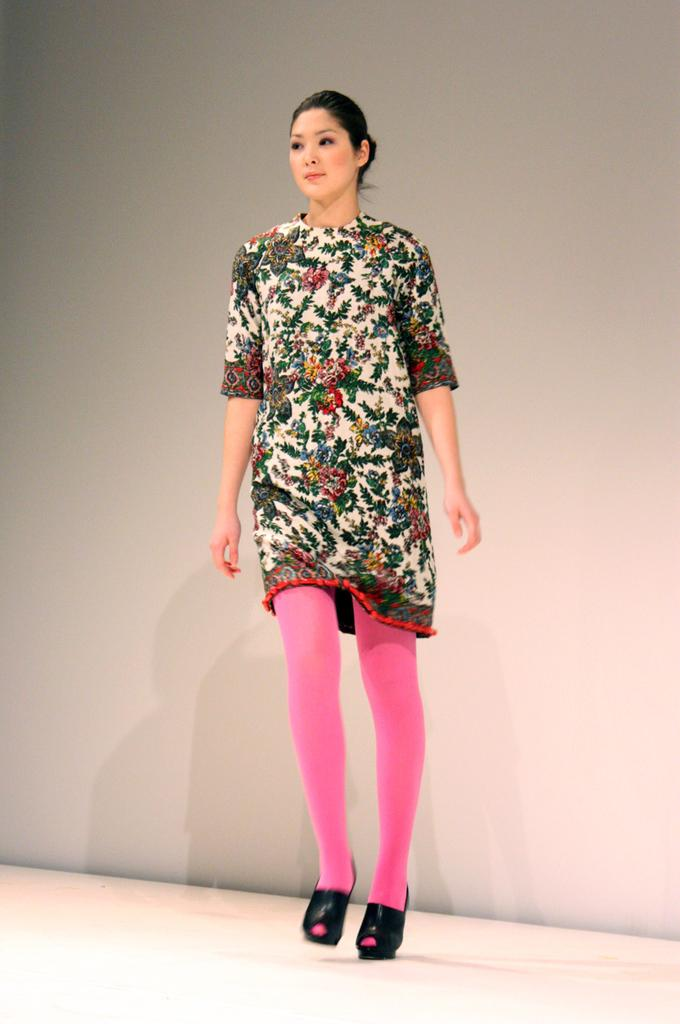Who is the main subject in the image? There is a woman in the image. What is the woman doing in the image? The woman is walking on the floor. What can be seen in the background of the image? There is a wall in the background of the image. How many cherries can be seen in the woman's hand in the image? There are no cherries or hands visible in the image; it only features a woman walking on the floor with a wall in the background. 